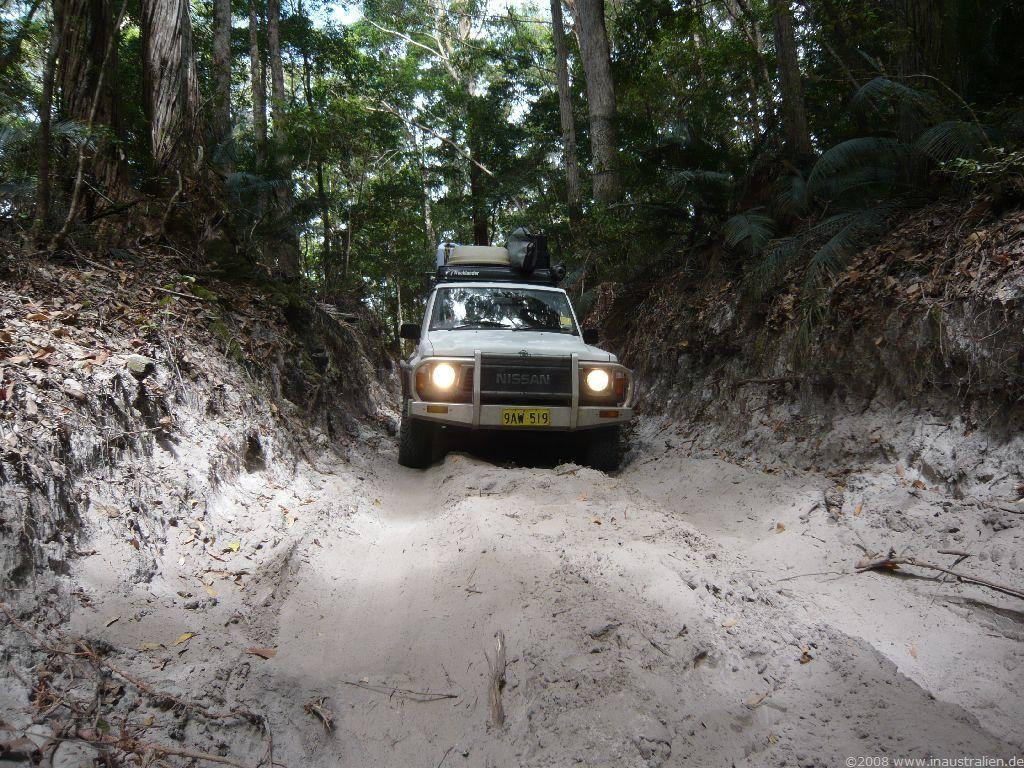What is the main subject of the image? There is a car in the image. What is the condition of the car? The car appears to be covered in mud. What type of natural environment is visible in the image? There are trees in the image. What is visible in the background of the image? The sky is visible in the image. Can you tell me how many quince are hanging from the trees in the image? There are no quince visible in the image; only trees are present. What type of legal advice is the lawyer providing in the image? There is no lawyer present in the image, so it is not possible to determine what type of legal advice might be provided. 